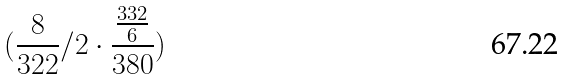<formula> <loc_0><loc_0><loc_500><loc_500>( \frac { 8 } { 3 2 2 } / 2 \cdot \frac { \frac { 3 3 2 } { 6 } } { 3 8 0 } )</formula> 